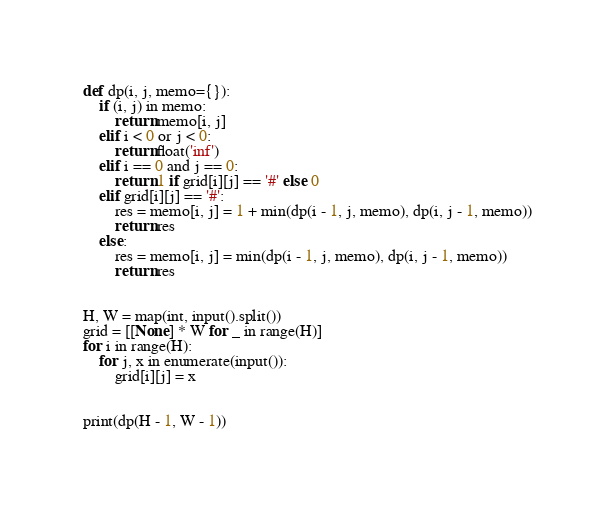<code> <loc_0><loc_0><loc_500><loc_500><_Python_>def dp(i, j, memo={}):
    if (i, j) in memo:
        return memo[i, j]
    elif i < 0 or j < 0:
        return float('inf')
    elif i == 0 and j == 0:
        return 1 if grid[i][j] == '#' else 0
    elif grid[i][j] == '#':
        res = memo[i, j] = 1 + min(dp(i - 1, j, memo), dp(i, j - 1, memo))
        return res
    else:
        res = memo[i, j] = min(dp(i - 1, j, memo), dp(i, j - 1, memo))
        return res


H, W = map(int, input().split())
grid = [[None] * W for _ in range(H)]
for i in range(H):
    for j, x in enumerate(input()):
        grid[i][j] = x


print(dp(H - 1, W - 1))</code> 